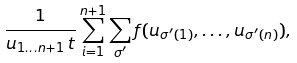Convert formula to latex. <formula><loc_0><loc_0><loc_500><loc_500>\frac { 1 } { u _ { 1 \dots n + 1 } \, t } \sum _ { i = 1 } ^ { n + 1 } \sum _ { \sigma ^ { \prime } } f ( u _ { \sigma ^ { \prime } ( 1 ) } , \dots , u _ { \sigma ^ { \prime } ( n ) } ) ,</formula> 